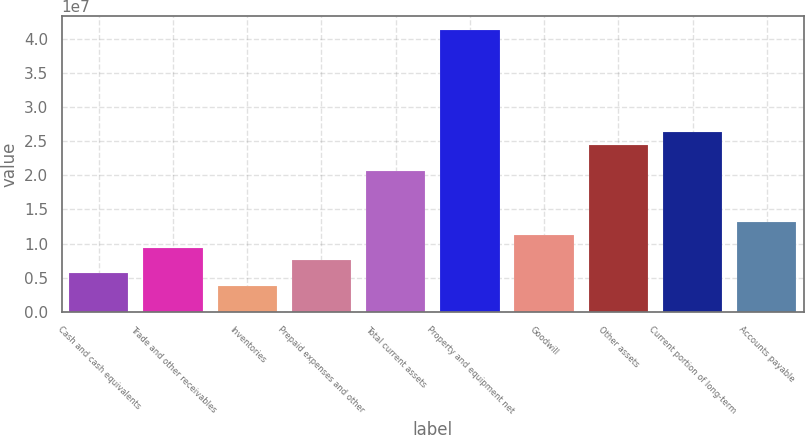<chart> <loc_0><loc_0><loc_500><loc_500><bar_chart><fcel>Cash and cash equivalents<fcel>Trade and other receivables<fcel>Inventories<fcel>Prepaid expenses and other<fcel>Total current assets<fcel>Property and equipment net<fcel>Goodwill<fcel>Other assets<fcel>Current portion of long-term<fcel>Accounts payable<nl><fcel>5.63497e+06<fcel>9.39006e+06<fcel>3.75743e+06<fcel>7.51251e+06<fcel>2.06553e+07<fcel>4.13083e+07<fcel>1.12676e+07<fcel>2.44104e+07<fcel>2.6288e+07<fcel>1.31451e+07<nl></chart> 